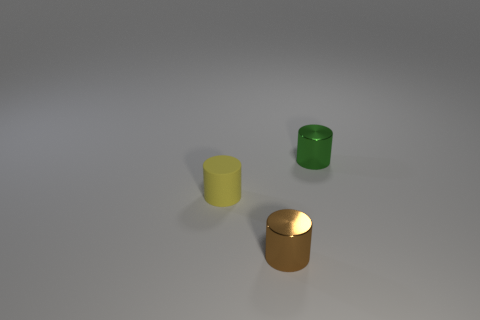There is a tiny green thing that is to the right of the small shiny cylinder that is on the left side of the green cylinder; how many metallic things are to the left of it?
Keep it short and to the point. 1. Do the shiny thing on the right side of the tiny brown shiny cylinder and the small yellow object have the same shape?
Your response must be concise. Yes. There is a tiny shiny cylinder behind the yellow matte thing; is there a tiny metallic cylinder that is behind it?
Ensure brevity in your answer.  No. How many brown things are there?
Your answer should be very brief. 1. What is the color of the tiny object that is on the left side of the green metallic cylinder and on the right side of the yellow thing?
Give a very brief answer. Brown. What is the size of the green metallic thing that is the same shape as the small yellow rubber thing?
Give a very brief answer. Small. How many other yellow matte things have the same size as the yellow object?
Provide a short and direct response. 0. What material is the yellow cylinder?
Provide a succinct answer. Rubber. Are there any brown metallic things in front of the small brown object?
Provide a succinct answer. No. There is another thing that is the same material as the green object; what size is it?
Make the answer very short. Small. 